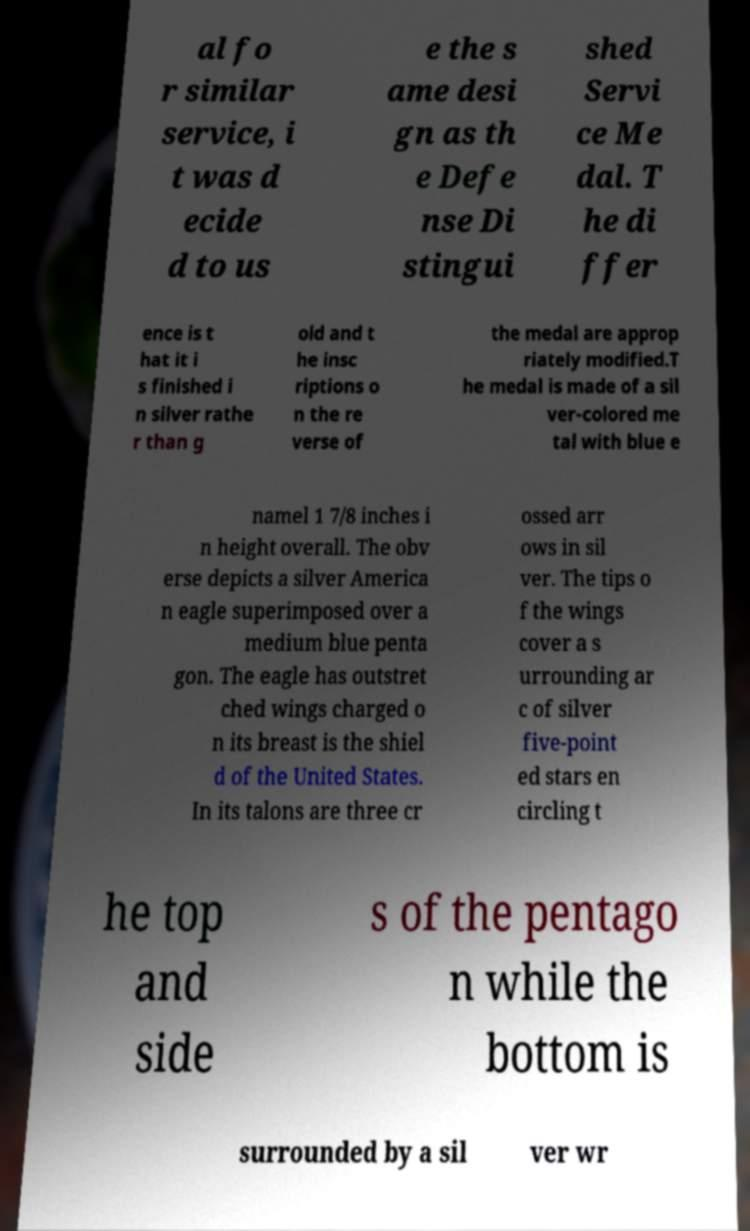There's text embedded in this image that I need extracted. Can you transcribe it verbatim? al fo r similar service, i t was d ecide d to us e the s ame desi gn as th e Defe nse Di stingui shed Servi ce Me dal. T he di ffer ence is t hat it i s finished i n silver rathe r than g old and t he insc riptions o n the re verse of the medal are approp riately modified.T he medal is made of a sil ver-colored me tal with blue e namel 1 7/8 inches i n height overall. The obv erse depicts a silver America n eagle superimposed over a medium blue penta gon. The eagle has outstret ched wings charged o n its breast is the shiel d of the United States. In its talons are three cr ossed arr ows in sil ver. The tips o f the wings cover a s urrounding ar c of silver five-point ed stars en circling t he top and side s of the pentago n while the bottom is surrounded by a sil ver wr 